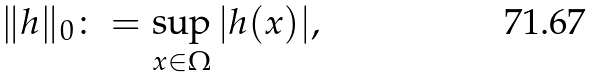<formula> <loc_0><loc_0><loc_500><loc_500>\| h \| _ { 0 } \colon = \sup _ { x \in \Omega } | h ( x ) | ,</formula> 